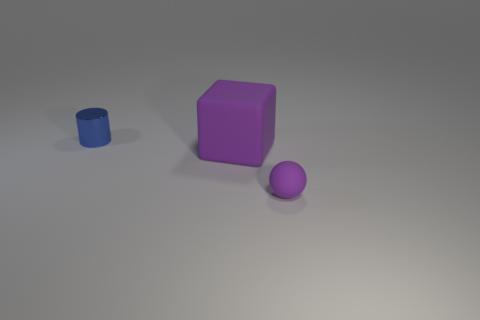Add 1 yellow blocks. How many objects exist? 4 Subtract all small purple spheres. Subtract all yellow rubber blocks. How many objects are left? 2 Add 1 large purple matte things. How many large purple matte things are left? 2 Add 3 tiny metal objects. How many tiny metal objects exist? 4 Subtract 0 purple cylinders. How many objects are left? 3 Subtract all cylinders. How many objects are left? 2 Subtract all red cylinders. Subtract all purple spheres. How many cylinders are left? 1 